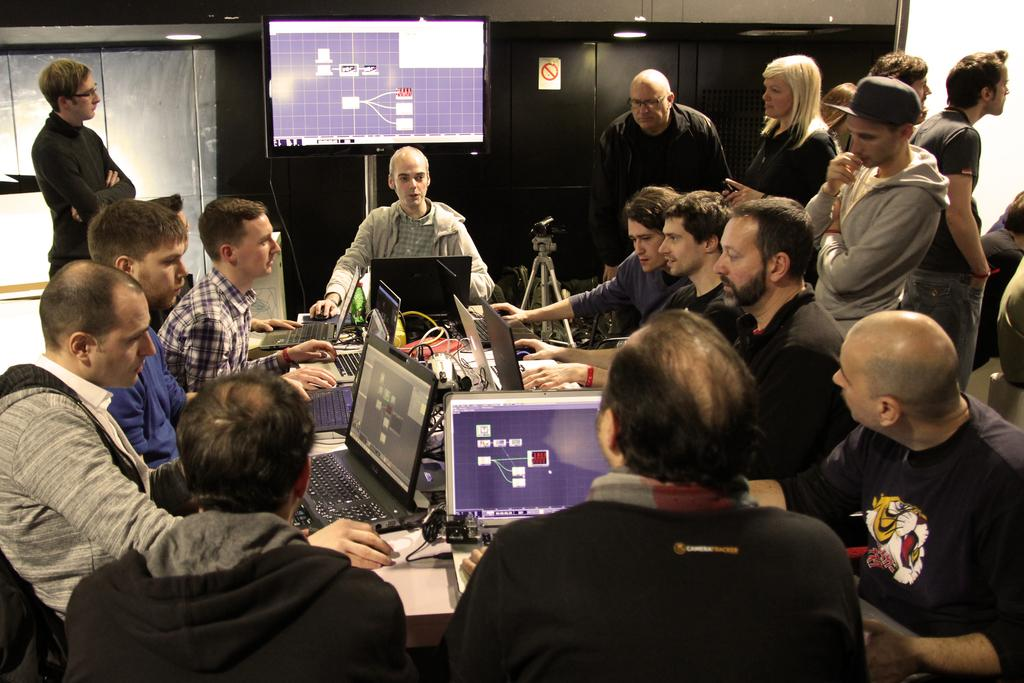How many people are in the image? There is a group of people in the image, but the exact number is not specified. What are the people in the image doing? Some people are standing, while others are sitting in chairs. What electronic devices can be seen in the image? Laptops, a camera, and a television are visible in the image. What type of furniture is present in the image? There are chairs and cupboards in the image. What is used for illumination in the image? Lights are present in the image. What type of soup is being served in the image? There is no soup present in the image. What scientific theory is being discussed by the people in the image? There is no indication of a scientific discussion or theory in the image. 